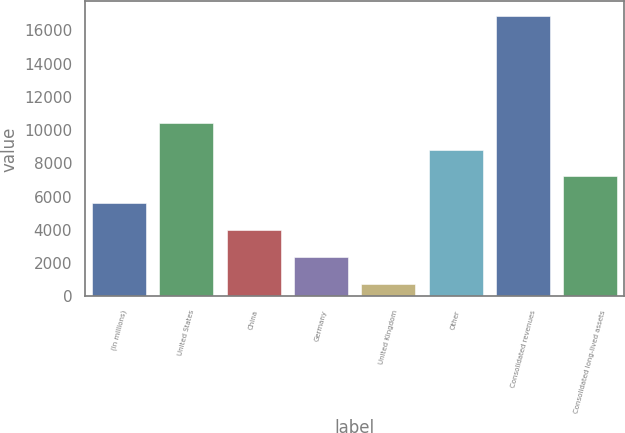<chart> <loc_0><loc_0><loc_500><loc_500><bar_chart><fcel>(In millions)<fcel>United States<fcel>China<fcel>Germany<fcel>United Kingdom<fcel>Other<fcel>Consolidated revenues<fcel>Consolidated long-lived assets<nl><fcel>5595.03<fcel>10435.6<fcel>3981.52<fcel>2368.01<fcel>754.5<fcel>8822.05<fcel>16889.6<fcel>7208.54<nl></chart> 